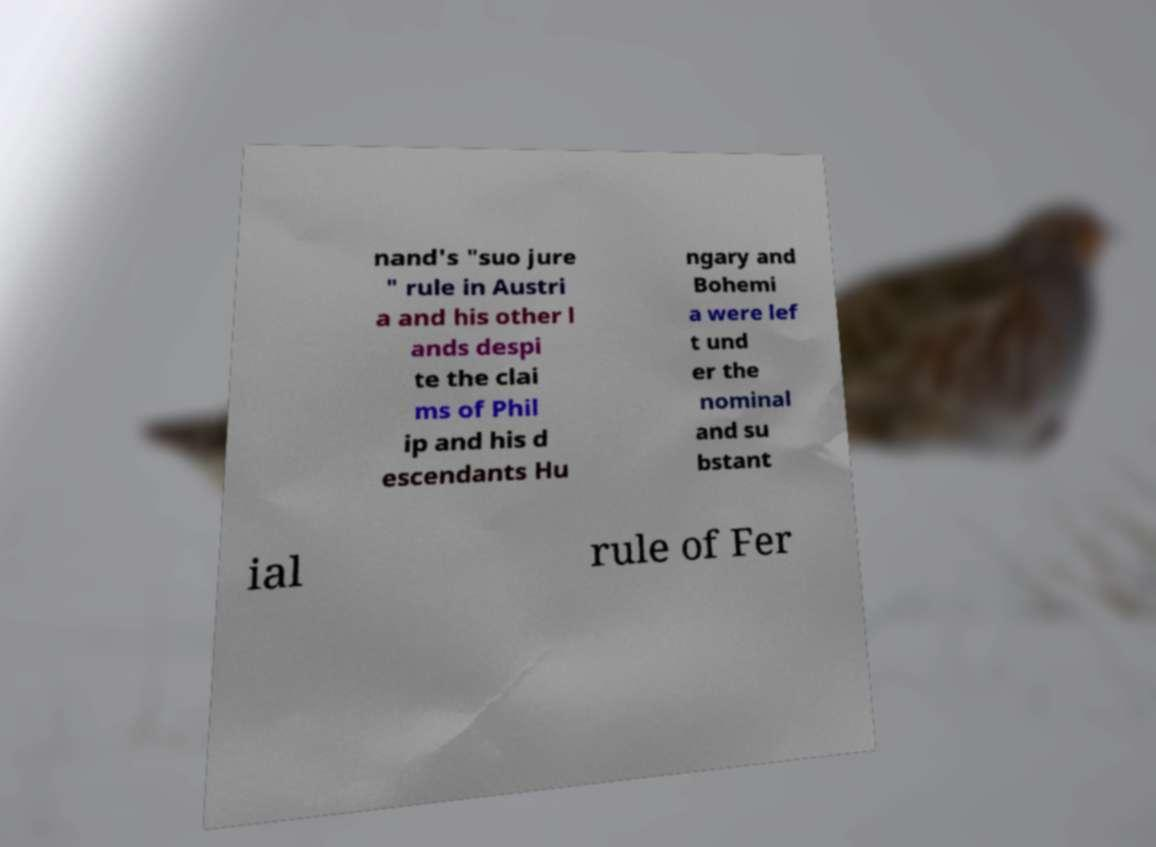Could you assist in decoding the text presented in this image and type it out clearly? nand's "suo jure " rule in Austri a and his other l ands despi te the clai ms of Phil ip and his d escendants Hu ngary and Bohemi a were lef t und er the nominal and su bstant ial rule of Fer 